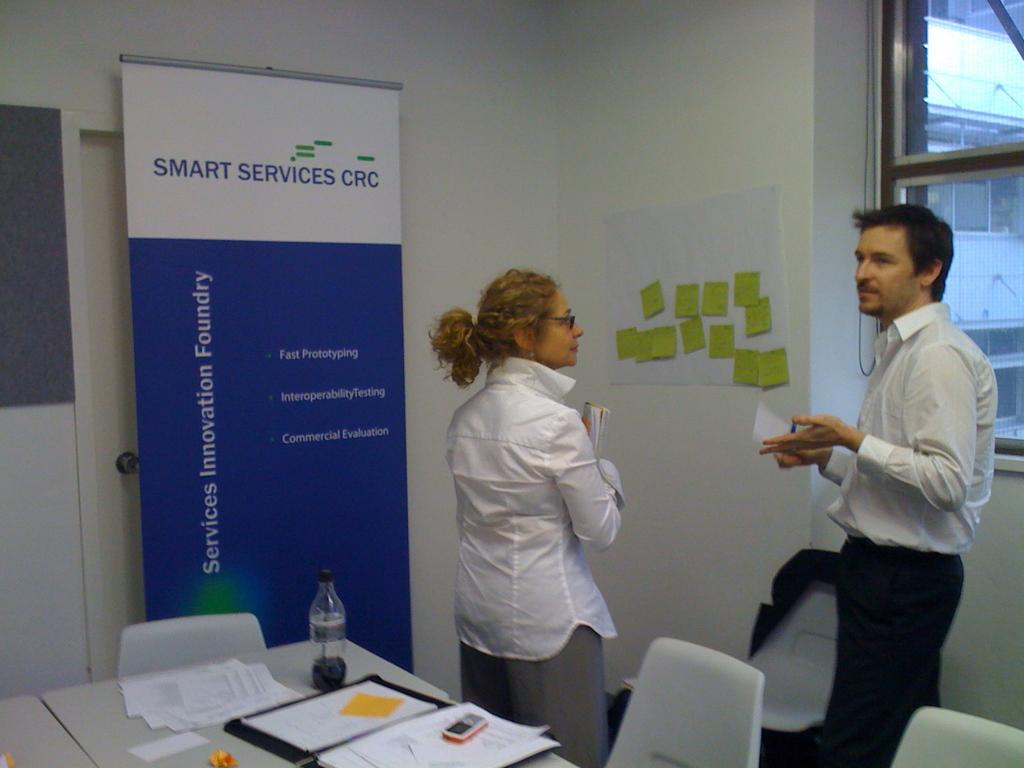<image>
Offer a succinct explanation of the picture presented. Two people have a conversation in front of Smart Services CRC banner. 